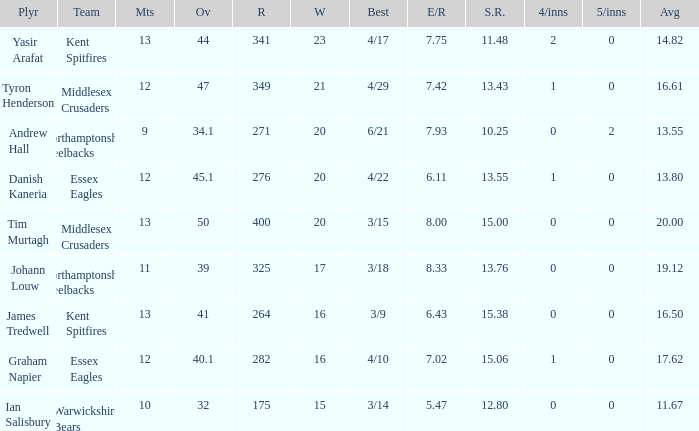Name the least matches for runs being 276 12.0. 